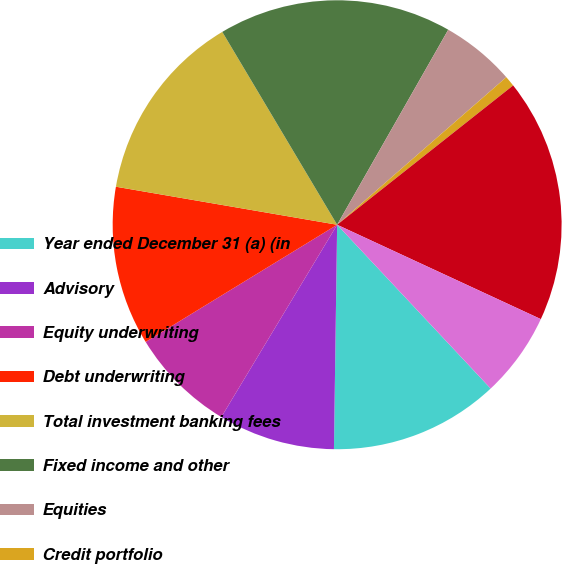<chart> <loc_0><loc_0><loc_500><loc_500><pie_chart><fcel>Year ended December 31 (a) (in<fcel>Advisory<fcel>Equity underwriting<fcel>Debt underwriting<fcel>Total investment banking fees<fcel>Fixed income and other<fcel>Equities<fcel>Credit portfolio<fcel>Total trading-related revenue<fcel>Lending & deposit related fees<nl><fcel>12.21%<fcel>8.4%<fcel>7.63%<fcel>11.45%<fcel>13.74%<fcel>16.79%<fcel>5.34%<fcel>0.76%<fcel>17.56%<fcel>6.11%<nl></chart> 